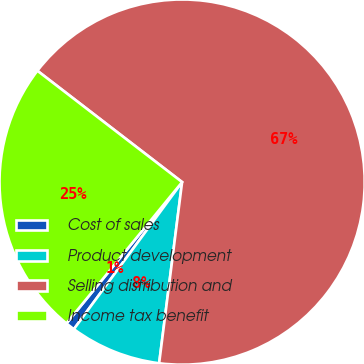Convert chart to OTSL. <chart><loc_0><loc_0><loc_500><loc_500><pie_chart><fcel>Cost of sales<fcel>Product development<fcel>Selling distribution and<fcel>Income tax benefit<nl><fcel>0.82%<fcel>8.09%<fcel>66.57%<fcel>24.52%<nl></chart> 